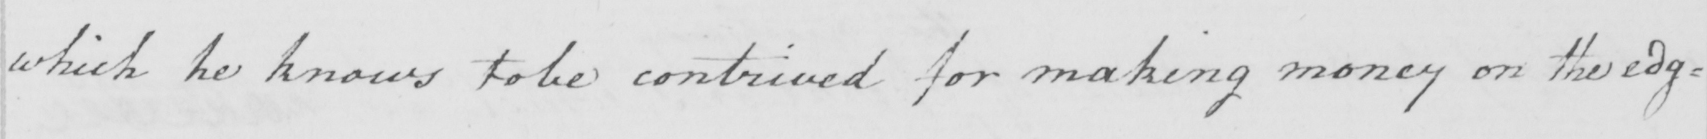Can you read and transcribe this handwriting? which he knows to be contrived for making money on the edg= 